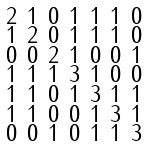<formula> <loc_0><loc_0><loc_500><loc_500>\begin{smallmatrix} 2 & 1 & 0 & 1 & 1 & 1 & 0 \\ 1 & 2 & 0 & 1 & 1 & 1 & 0 \\ 0 & 0 & 2 & 1 & 0 & 0 & 1 \\ 1 & 1 & 1 & 3 & 1 & 0 & 0 \\ 1 & 1 & 0 & 1 & 3 & 1 & 1 \\ 1 & 1 & 0 & 0 & 1 & 3 & 1 \\ 0 & 0 & 1 & 0 & 1 & 1 & 3 \end{smallmatrix}</formula> 